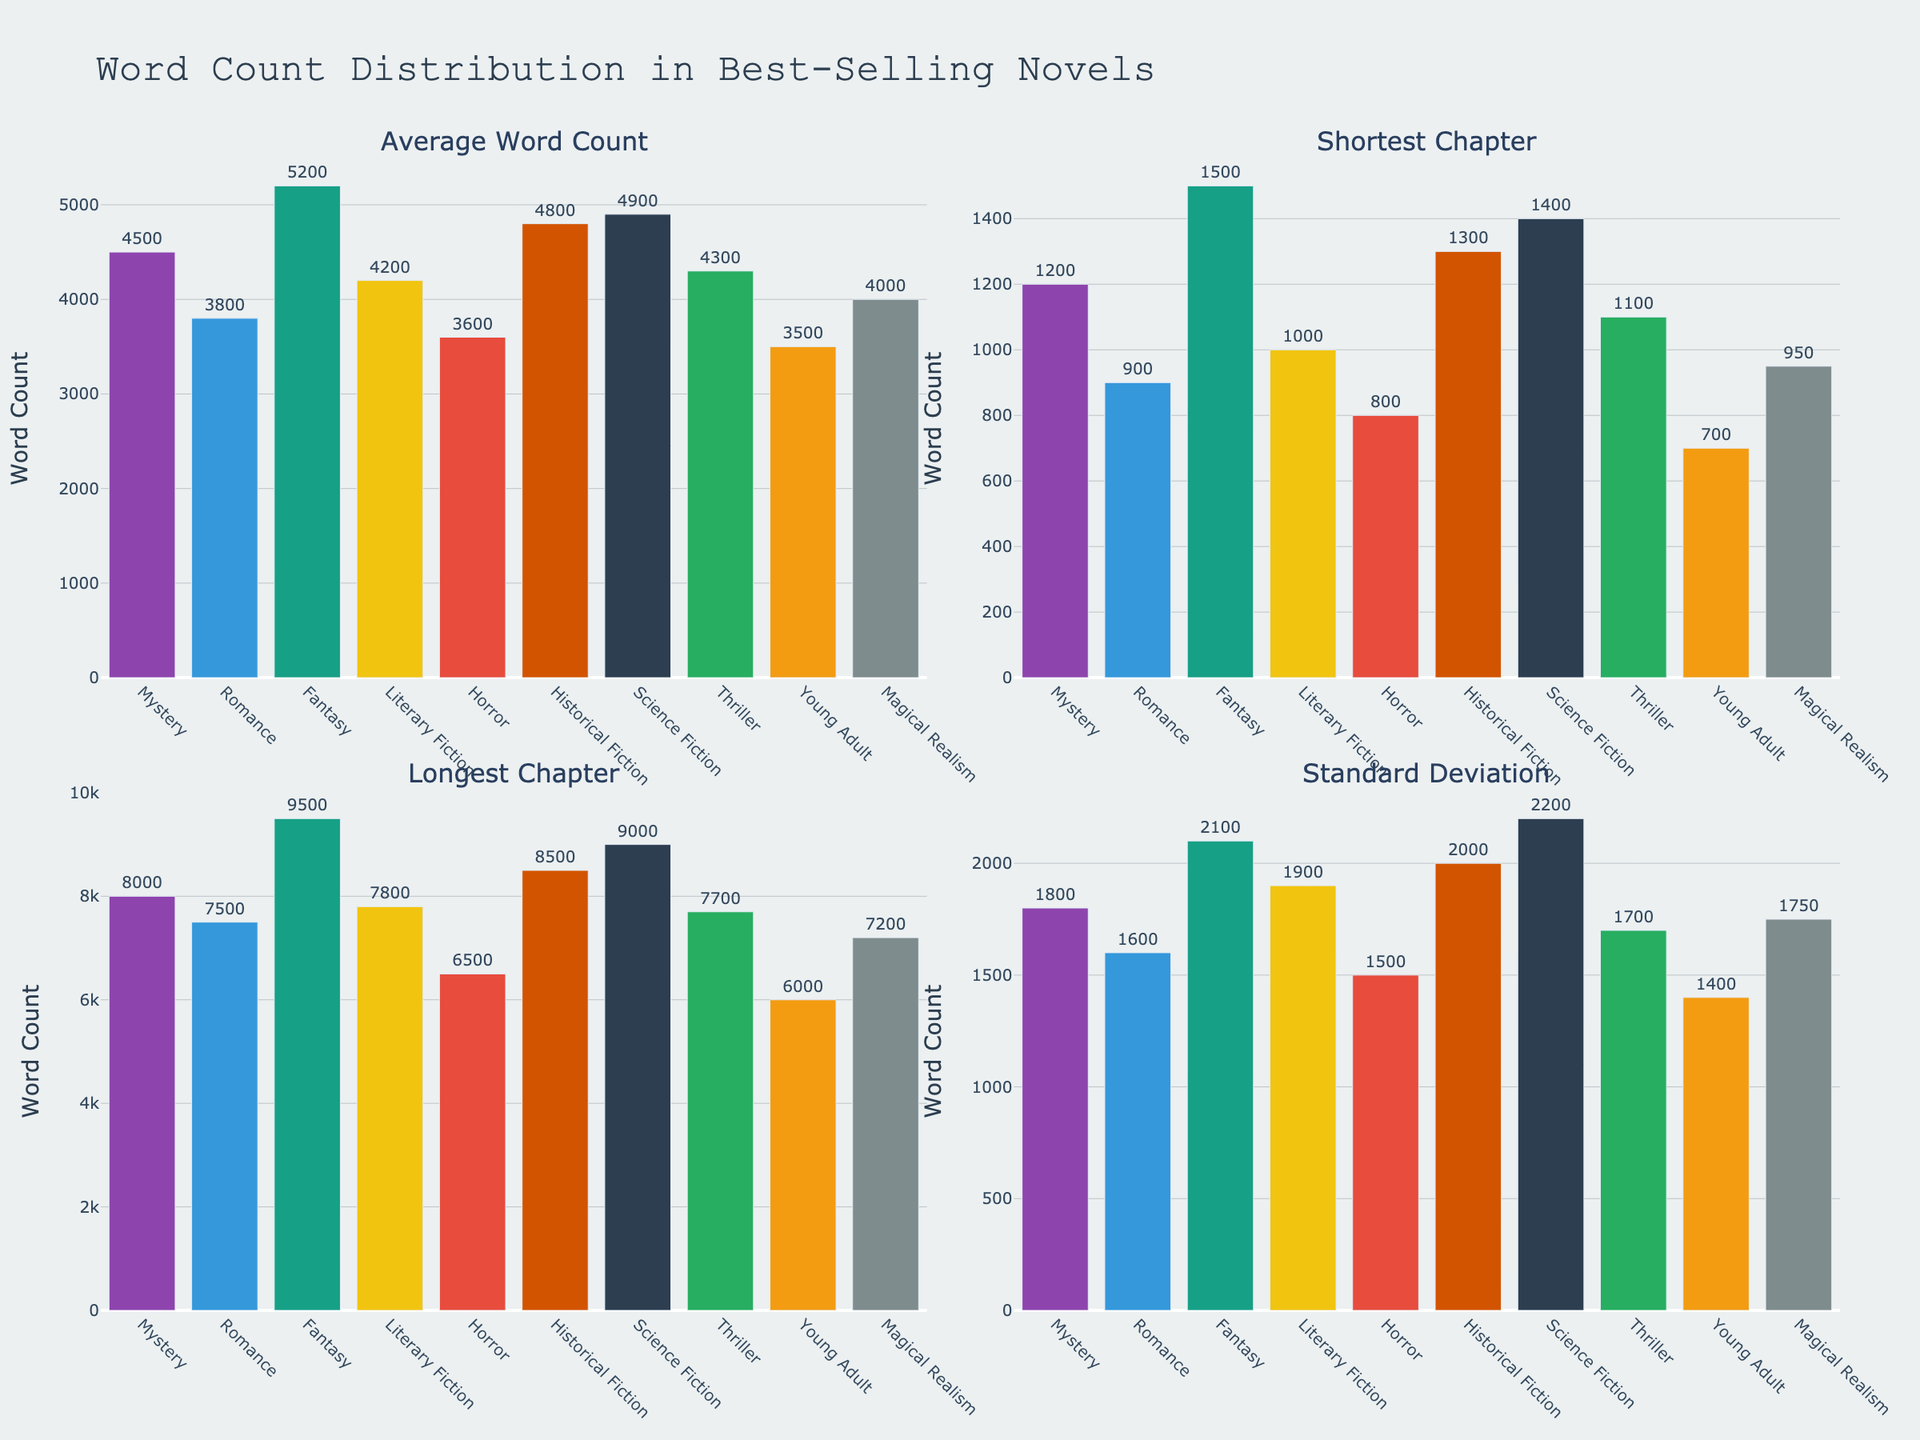What category has the highest percentage in the first pie chart? The first pie chart labeled "Content Categories" shows the distribution with different colors. Family Vlogs occupy the largest segment.
Answer: Family Vlogs How much percentage does 'Gaming' contribute in the first pie chart? In the first pie chart labeled "Content Categories", the segment for 'Gaming' is marked. The percentage labeled is 4%.
Answer: 4% What is the combined percentage of 'Challenges' and 'Travel Adventures' in the "Content Categories" pie chart? The pie chart labeled "Content Categories" shows 'Challenges' at 20% and 'Travel Adventures' at 15%. Adding these together gives 20% + 15%.
Answer: 35% Which category contributes the least in both pie charts? By examining both pie charts, 'DIY Projects' are the smallest segment in both charts with only 3%.
Answer: DIY Projects How does the percentage of 'Music Videos' compare to 'Cooking & Food' in the "Content Categories" pie chart? In the pie chart labeled "Content Categories", 'Music Videos' have a percentage of 8% while 'Cooking & Food' have 5%. Since 8% is greater than 5%, 'Music Videos' contribute more.
Answer: Music Videos have a higher percentage What percentage do 'Family Vlogs', 'Challenges', and 'Travel Adventures' combined contribute out of the total in the "Distribution" pie chart? In the "Distribution" pie chart, 'Family Vlogs' are 35%, 'Challenges' are 20%, and 'Travel Adventures' are 15%. Adding these together gives 35% + 20% + 15%.
Answer: 70% In the "Categories" pie chart, which category has a percentage value between 5% and 10%? Looking at the "Categories" pie chart, 'Pranks' have 10%, 'Music Videos' have 8%, and 'Cooking & Food' have 5%. Only 'Music Videos' fall strictly between 5% and 10%.
Answer: Music Videos What is the total percentage of categories that contribute less than 10% in the "Content Categories" pie chart? Categories contributing less than 10% are 'Music Videos' (8%), 'Cooking & Food' (5%), 'Gaming' (4%), and 'DIY Projects' (3%). Summing these gives 8% + 5% + 4% + 3%.
Answer: 20% What's the difference in percentage between 'Family Vlogs' and 'Challenges' in the first pie chart? The "Content Categories" pie chart shows 'Family Vlogs' at 35% and 'Challenges' at 20%. The difference is 35% - 20%.
Answer: 15% How is the second pie chart different from the first pie chart apart from the labeling? The first pie chart labeled "Content Categories" includes text information as 'label+percent' with a hole of 0.3, while the second chart labeled "Content Distribution" displays 'value' with a hole of 0.5.
Answer: Different text information and hole size 